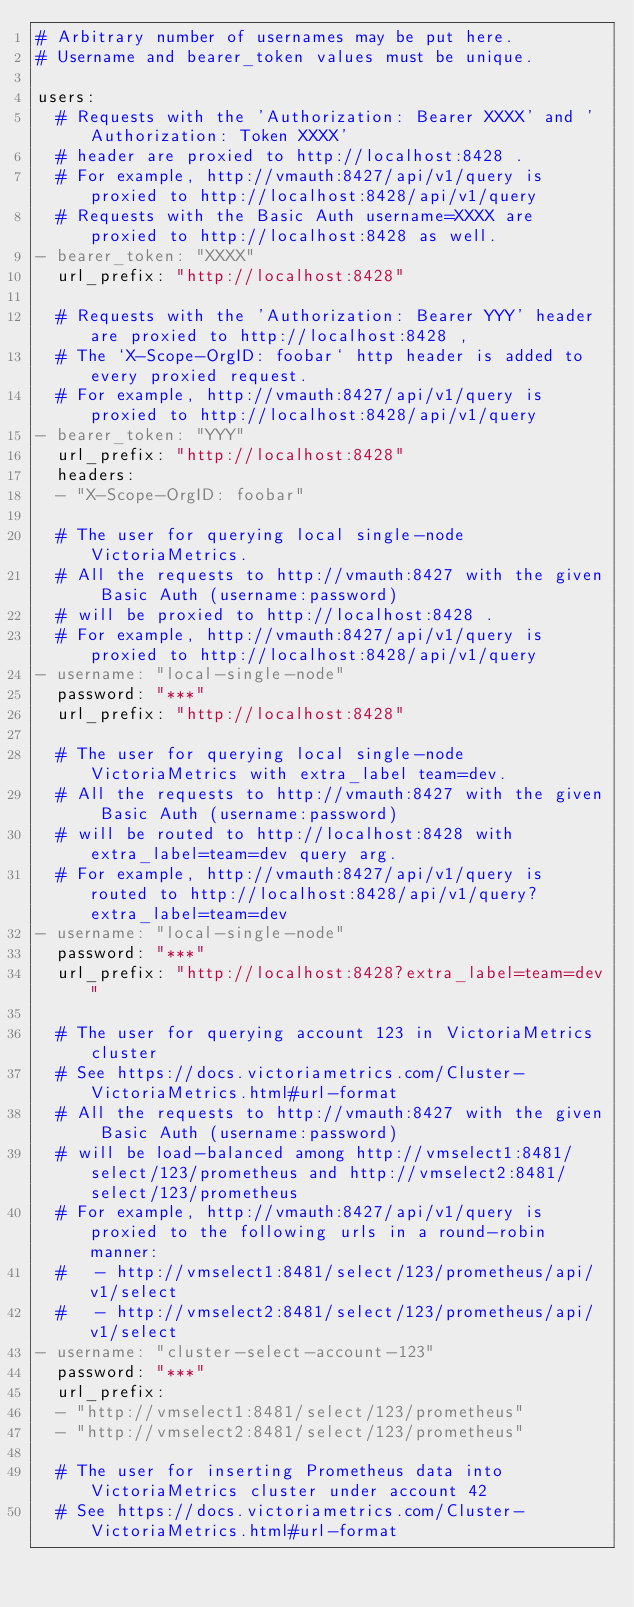Convert code to text. <code><loc_0><loc_0><loc_500><loc_500><_YAML_># Arbitrary number of usernames may be put here.
# Username and bearer_token values must be unique.

users:
  # Requests with the 'Authorization: Bearer XXXX' and 'Authorization: Token XXXX'
  # header are proxied to http://localhost:8428 .
  # For example, http://vmauth:8427/api/v1/query is proxied to http://localhost:8428/api/v1/query
  # Requests with the Basic Auth username=XXXX are proxied to http://localhost:8428 as well.
- bearer_token: "XXXX"
  url_prefix: "http://localhost:8428"

  # Requests with the 'Authorization: Bearer YYY' header are proxied to http://localhost:8428 ,
  # The `X-Scope-OrgID: foobar` http header is added to every proxied request.
  # For example, http://vmauth:8427/api/v1/query is proxied to http://localhost:8428/api/v1/query
- bearer_token: "YYY"
  url_prefix: "http://localhost:8428"
  headers:
  - "X-Scope-OrgID: foobar"

  # The user for querying local single-node VictoriaMetrics.
  # All the requests to http://vmauth:8427 with the given Basic Auth (username:password)
  # will be proxied to http://localhost:8428 .
  # For example, http://vmauth:8427/api/v1/query is proxied to http://localhost:8428/api/v1/query
- username: "local-single-node"
  password: "***"
  url_prefix: "http://localhost:8428"

  # The user for querying local single-node VictoriaMetrics with extra_label team=dev.
  # All the requests to http://vmauth:8427 with the given Basic Auth (username:password)
  # will be routed to http://localhost:8428 with extra_label=team=dev query arg.
  # For example, http://vmauth:8427/api/v1/query is routed to http://localhost:8428/api/v1/query?extra_label=team=dev
- username: "local-single-node"
  password: "***"
  url_prefix: "http://localhost:8428?extra_label=team=dev"

  # The user for querying account 123 in VictoriaMetrics cluster
  # See https://docs.victoriametrics.com/Cluster-VictoriaMetrics.html#url-format
  # All the requests to http://vmauth:8427 with the given Basic Auth (username:password)
  # will be load-balanced among http://vmselect1:8481/select/123/prometheus and http://vmselect2:8481/select/123/prometheus
  # For example, http://vmauth:8427/api/v1/query is proxied to the following urls in a round-robin manner:
  #   - http://vmselect1:8481/select/123/prometheus/api/v1/select
  #   - http://vmselect2:8481/select/123/prometheus/api/v1/select
- username: "cluster-select-account-123"
  password: "***"
  url_prefix:
  - "http://vmselect1:8481/select/123/prometheus"
  - "http://vmselect2:8481/select/123/prometheus"

  # The user for inserting Prometheus data into VictoriaMetrics cluster under account 42
  # See https://docs.victoriametrics.com/Cluster-VictoriaMetrics.html#url-format</code> 